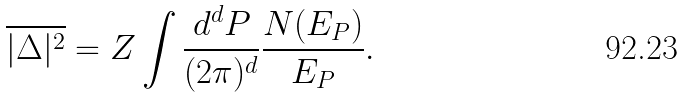Convert formula to latex. <formula><loc_0><loc_0><loc_500><loc_500>\overline { | \Delta | ^ { 2 } } = Z \int \frac { d ^ { d } { P } } { ( 2 \pi ) ^ { d } } \frac { N ( E _ { P } ) } { E _ { P } } .</formula> 